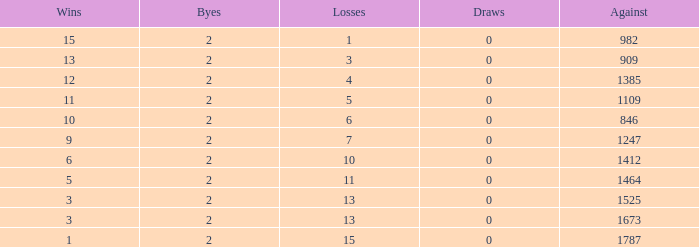When losses were less than 0 and opponents numbered 1247, what was the typical count of byes? None. 